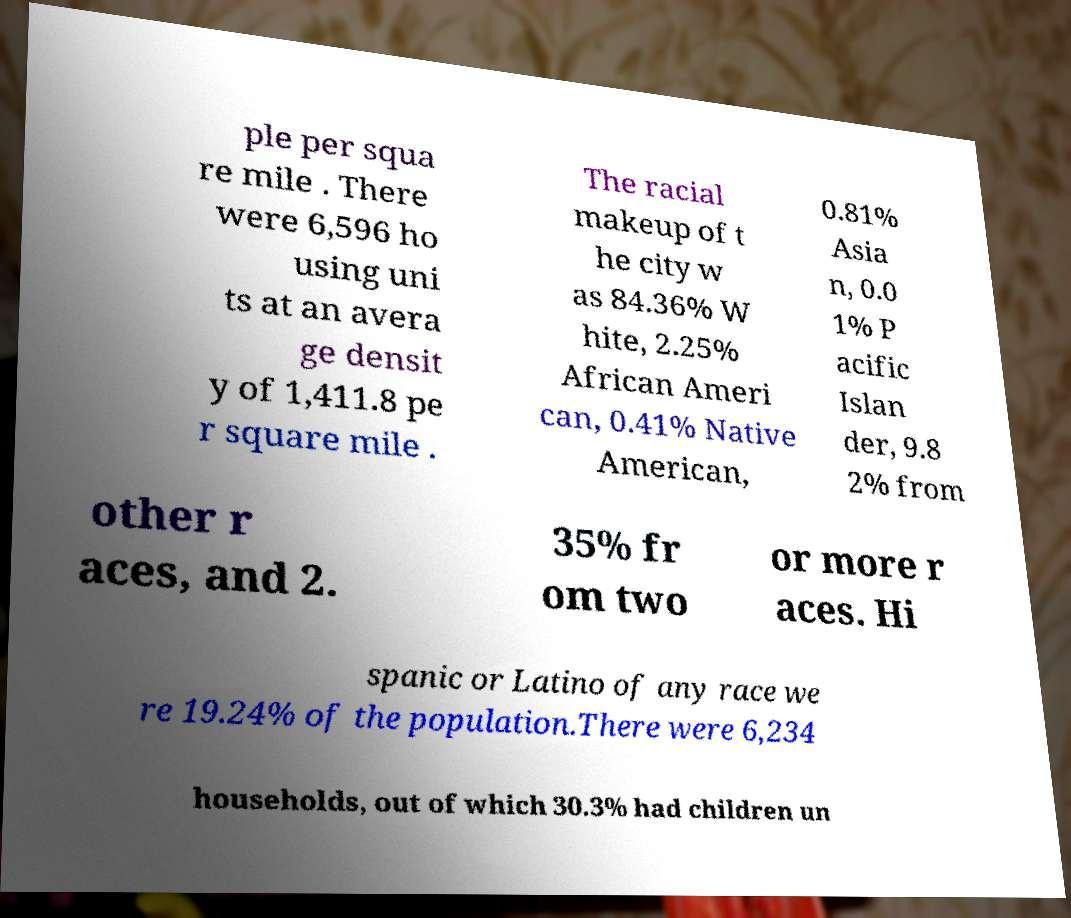Could you assist in decoding the text presented in this image and type it out clearly? ple per squa re mile . There were 6,596 ho using uni ts at an avera ge densit y of 1,411.8 pe r square mile . The racial makeup of t he city w as 84.36% W hite, 2.25% African Ameri can, 0.41% Native American, 0.81% Asia n, 0.0 1% P acific Islan der, 9.8 2% from other r aces, and 2. 35% fr om two or more r aces. Hi spanic or Latino of any race we re 19.24% of the population.There were 6,234 households, out of which 30.3% had children un 